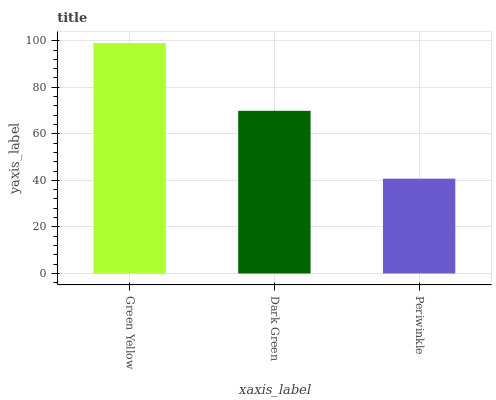Is Periwinkle the minimum?
Answer yes or no. Yes. Is Green Yellow the maximum?
Answer yes or no. Yes. Is Dark Green the minimum?
Answer yes or no. No. Is Dark Green the maximum?
Answer yes or no. No. Is Green Yellow greater than Dark Green?
Answer yes or no. Yes. Is Dark Green less than Green Yellow?
Answer yes or no. Yes. Is Dark Green greater than Green Yellow?
Answer yes or no. No. Is Green Yellow less than Dark Green?
Answer yes or no. No. Is Dark Green the high median?
Answer yes or no. Yes. Is Dark Green the low median?
Answer yes or no. Yes. Is Green Yellow the high median?
Answer yes or no. No. Is Green Yellow the low median?
Answer yes or no. No. 